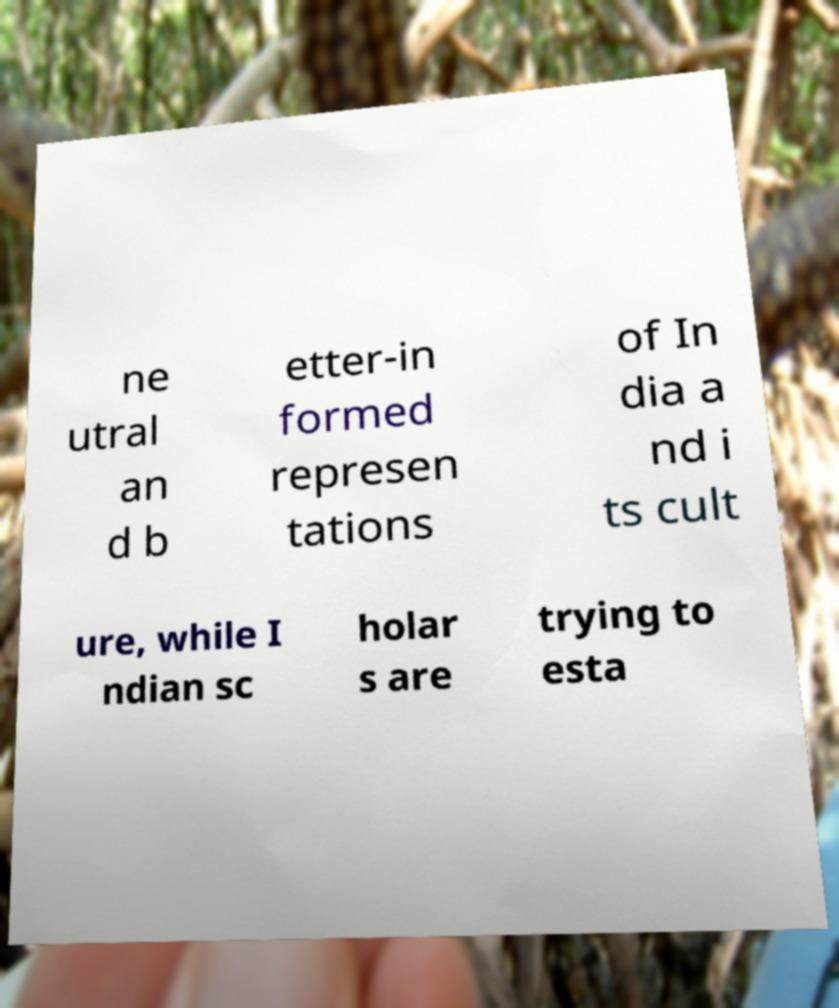I need the written content from this picture converted into text. Can you do that? ne utral an d b etter-in formed represen tations of In dia a nd i ts cult ure, while I ndian sc holar s are trying to esta 